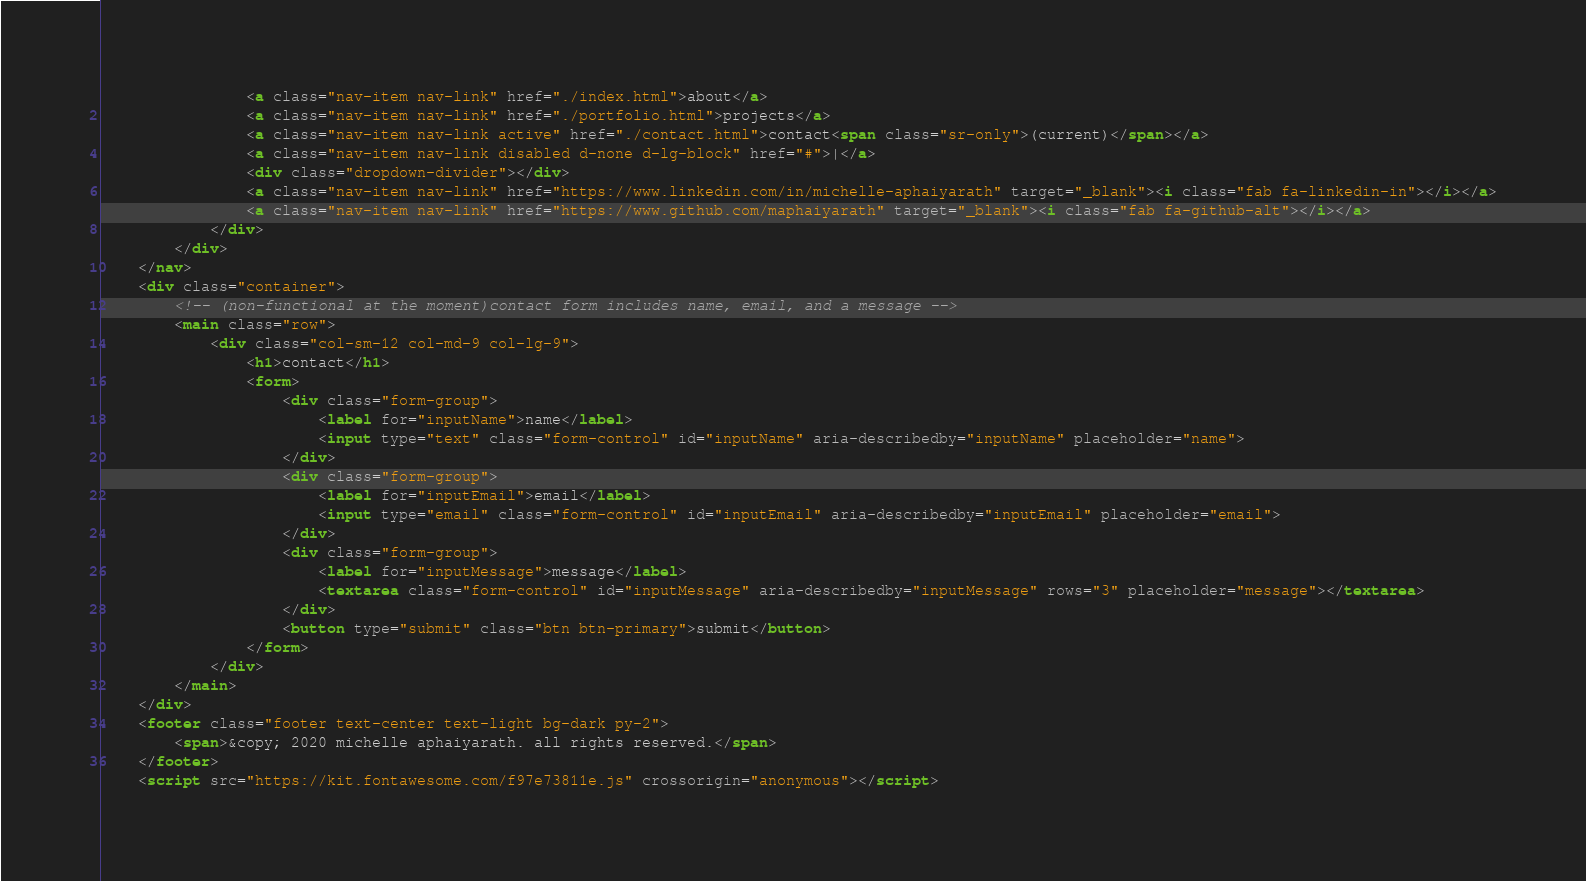Convert code to text. <code><loc_0><loc_0><loc_500><loc_500><_HTML_>                <a class="nav-item nav-link" href="./index.html">about</a>
                <a class="nav-item nav-link" href="./portfolio.html">projects</a>
                <a class="nav-item nav-link active" href="./contact.html">contact<span class="sr-only">(current)</span></a>
                <a class="nav-item nav-link disabled d-none d-lg-block" href="#">|</a>
                <div class="dropdown-divider"></div>
                <a class="nav-item nav-link" href="https://www.linkedin.com/in/michelle-aphaiyarath" target="_blank"><i class="fab fa-linkedin-in"></i></a>
                <a class="nav-item nav-link" href="https://www.github.com/maphaiyarath" target="_blank"><i class="fab fa-github-alt"></i></a>
            </div>
        </div>
    </nav>
    <div class="container">
        <!-- (non-functional at the moment)contact form includes name, email, and a message -->
        <main class="row">
            <div class="col-sm-12 col-md-9 col-lg-9">
                <h1>contact</h1>
                <form>
                    <div class="form-group">
                        <label for="inputName">name</label>
                        <input type="text" class="form-control" id="inputName" aria-describedby="inputName" placeholder="name">
                    </div>
                    <div class="form-group">
                        <label for="inputEmail">email</label>
                        <input type="email" class="form-control" id="inputEmail" aria-describedby="inputEmail" placeholder="email">
                    </div>
                    <div class="form-group">
                        <label for="inputMessage">message</label>
                        <textarea class="form-control" id="inputMessage" aria-describedby="inputMessage" rows="3" placeholder="message"></textarea>
                    </div>
                    <button type="submit" class="btn btn-primary">submit</button>
                </form>
            </div>
        </main>
    </div>
    <footer class="footer text-center text-light bg-dark py-2">
        <span>&copy; 2020 michelle aphaiyarath. all rights reserved.</span>
    </footer>
    <script src="https://kit.fontawesome.com/f97e73811e.js" crossorigin="anonymous"></script></code> 